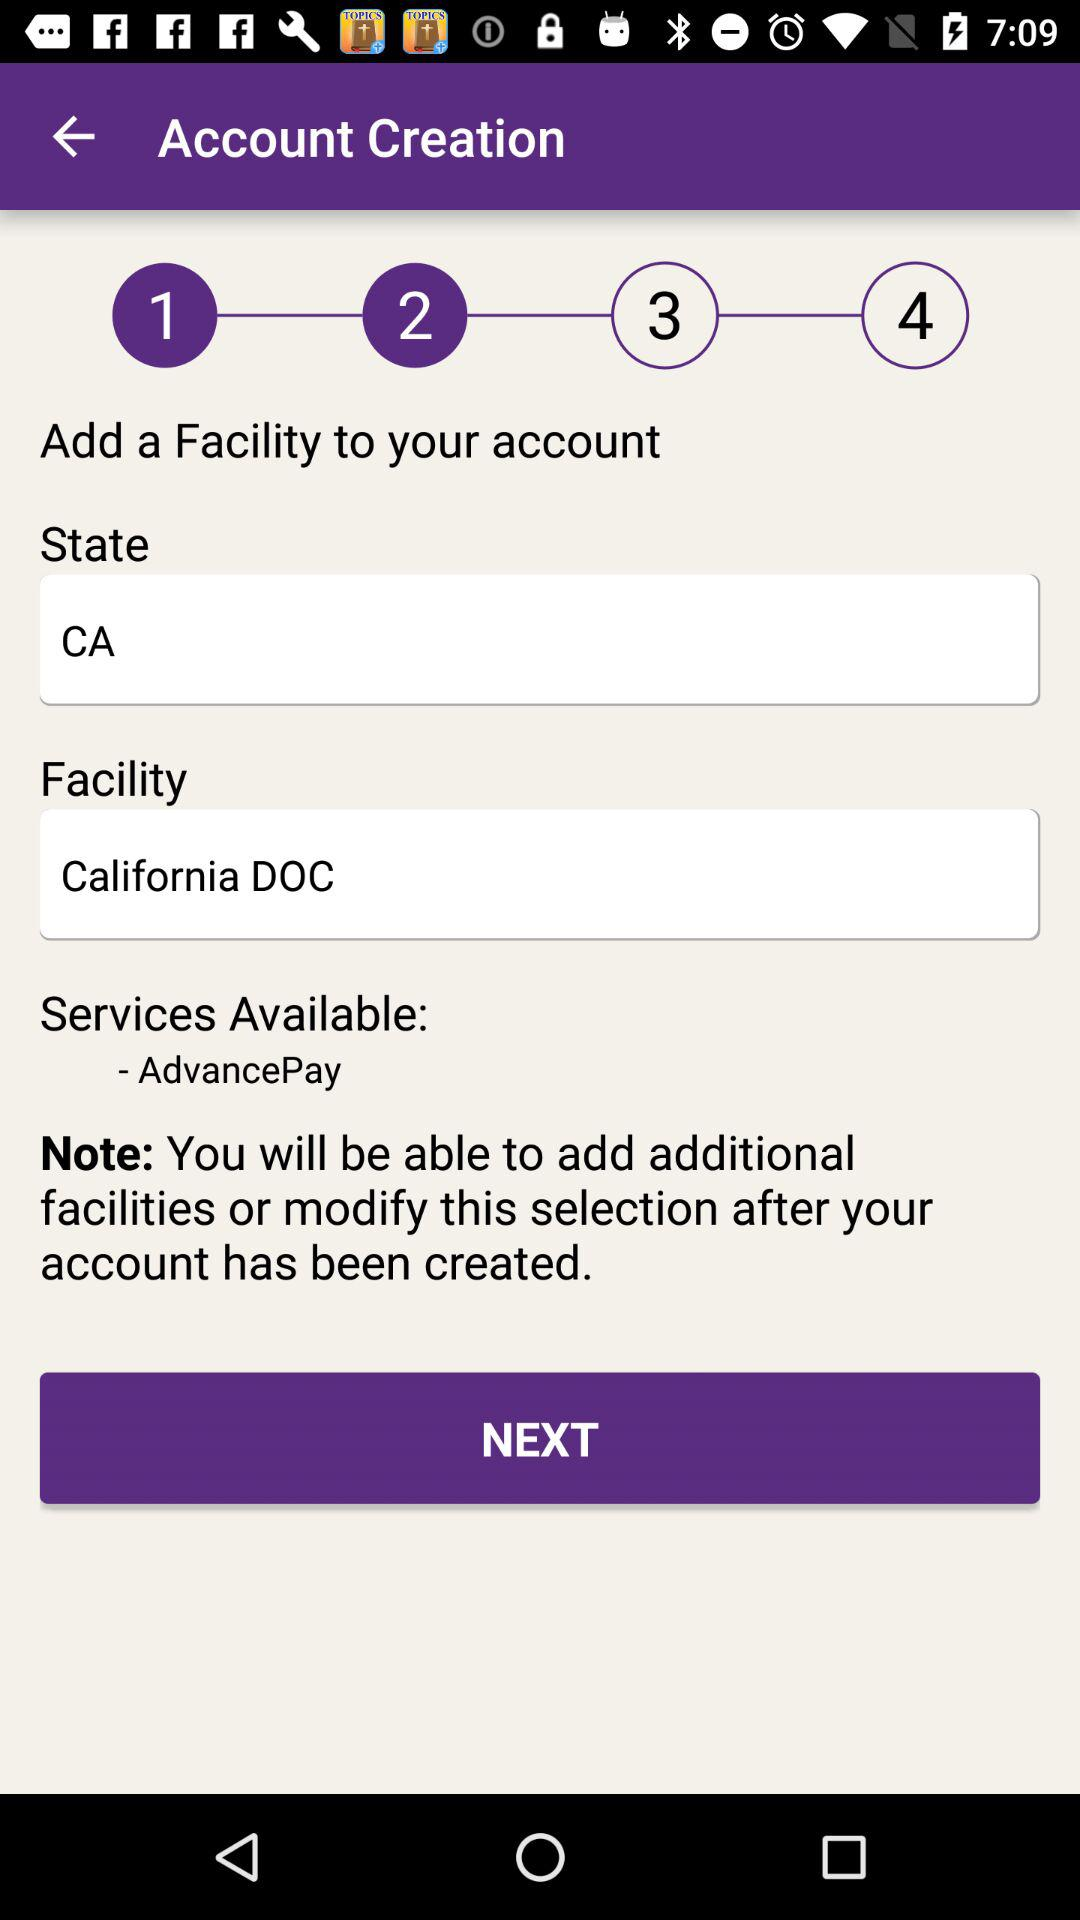What steps of account creation have been completed? There are 2 steps that have been completed. 